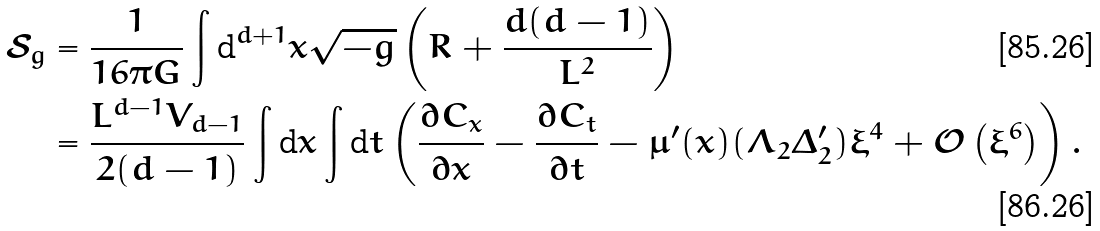Convert formula to latex. <formula><loc_0><loc_0><loc_500><loc_500>\mathcal { S } _ { g } & = \frac { 1 } { 1 6 \pi G } \int \text {d} ^ { d + 1 } x \sqrt { - g } \left ( R + \frac { d ( d - 1 ) } { L ^ { 2 } } \right ) \\ & = \frac { L ^ { d - 1 } V _ { d - 1 } } { 2 ( d - 1 ) } \int \text {d} x \int \text {d} t \left ( \frac { \partial C _ { x } } { \partial x } - \frac { \partial C _ { t } } { \partial t } - \mu ^ { \prime } ( x ) ( \Lambda _ { 2 } \Delta ^ { \prime } _ { 2 } ) \xi ^ { 4 } + \mathcal { O } \left ( \xi ^ { 6 } \right ) \right ) .</formula> 